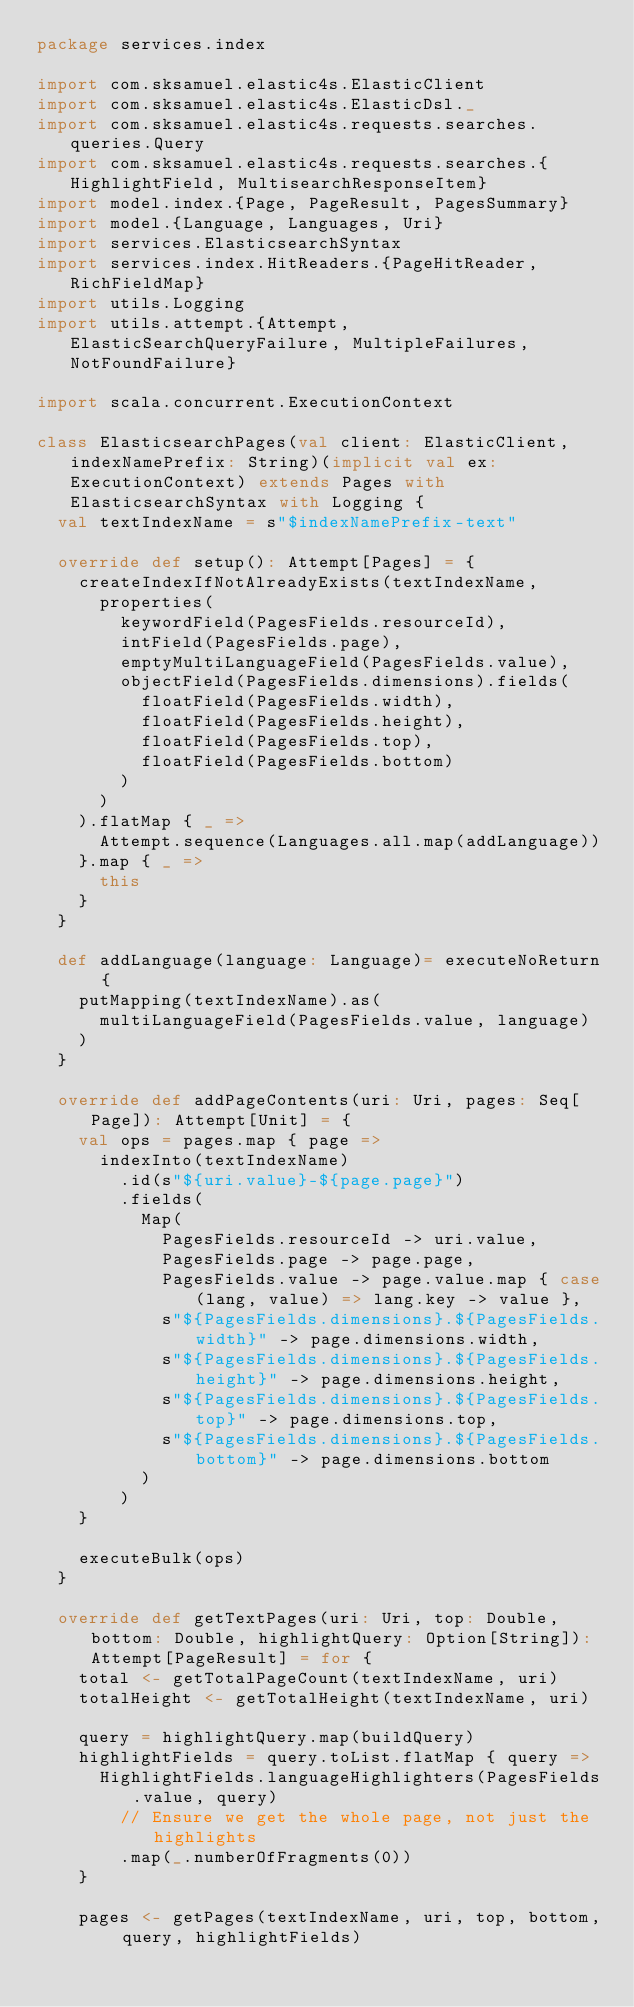<code> <loc_0><loc_0><loc_500><loc_500><_Scala_>package services.index

import com.sksamuel.elastic4s.ElasticClient
import com.sksamuel.elastic4s.ElasticDsl._
import com.sksamuel.elastic4s.requests.searches.queries.Query
import com.sksamuel.elastic4s.requests.searches.{HighlightField, MultisearchResponseItem}
import model.index.{Page, PageResult, PagesSummary}
import model.{Language, Languages, Uri}
import services.ElasticsearchSyntax
import services.index.HitReaders.{PageHitReader, RichFieldMap}
import utils.Logging
import utils.attempt.{Attempt, ElasticSearchQueryFailure, MultipleFailures, NotFoundFailure}

import scala.concurrent.ExecutionContext

class ElasticsearchPages(val client: ElasticClient, indexNamePrefix: String)(implicit val ex: ExecutionContext) extends Pages with ElasticsearchSyntax with Logging {
  val textIndexName = s"$indexNamePrefix-text"

  override def setup(): Attempt[Pages] = {
    createIndexIfNotAlreadyExists(textIndexName,
      properties(
        keywordField(PagesFields.resourceId),
        intField(PagesFields.page),
        emptyMultiLanguageField(PagesFields.value),
        objectField(PagesFields.dimensions).fields(
          floatField(PagesFields.width),
          floatField(PagesFields.height),
          floatField(PagesFields.top),
          floatField(PagesFields.bottom)
        )
      )
    ).flatMap { _ =>
      Attempt.sequence(Languages.all.map(addLanguage))
    }.map { _ =>
      this
    }
  }

  def addLanguage(language: Language)= executeNoReturn {
    putMapping(textIndexName).as(
      multiLanguageField(PagesFields.value, language)
    )
  }

  override def addPageContents(uri: Uri, pages: Seq[Page]): Attempt[Unit] = {
    val ops = pages.map { page =>
      indexInto(textIndexName)
        .id(s"${uri.value}-${page.page}")
        .fields(
          Map(
            PagesFields.resourceId -> uri.value,
            PagesFields.page -> page.page,
            PagesFields.value -> page.value.map { case(lang, value) => lang.key -> value },
            s"${PagesFields.dimensions}.${PagesFields.width}" -> page.dimensions.width,
            s"${PagesFields.dimensions}.${PagesFields.height}" -> page.dimensions.height,
            s"${PagesFields.dimensions}.${PagesFields.top}" -> page.dimensions.top,
            s"${PagesFields.dimensions}.${PagesFields.bottom}" -> page.dimensions.bottom
          )
        )
    }

    executeBulk(ops)
  }

  override def getTextPages(uri: Uri, top: Double, bottom: Double, highlightQuery: Option[String]): Attempt[PageResult] = for {
    total <- getTotalPageCount(textIndexName, uri)
    totalHeight <- getTotalHeight(textIndexName, uri)

    query = highlightQuery.map(buildQuery)
    highlightFields = query.toList.flatMap { query =>
      HighlightFields.languageHighlighters(PagesFields.value, query)
        // Ensure we get the whole page, not just the highlights
        .map(_.numberOfFragments(0))
    }

    pages <- getPages(textIndexName, uri, top, bottom, query, highlightFields)</code> 